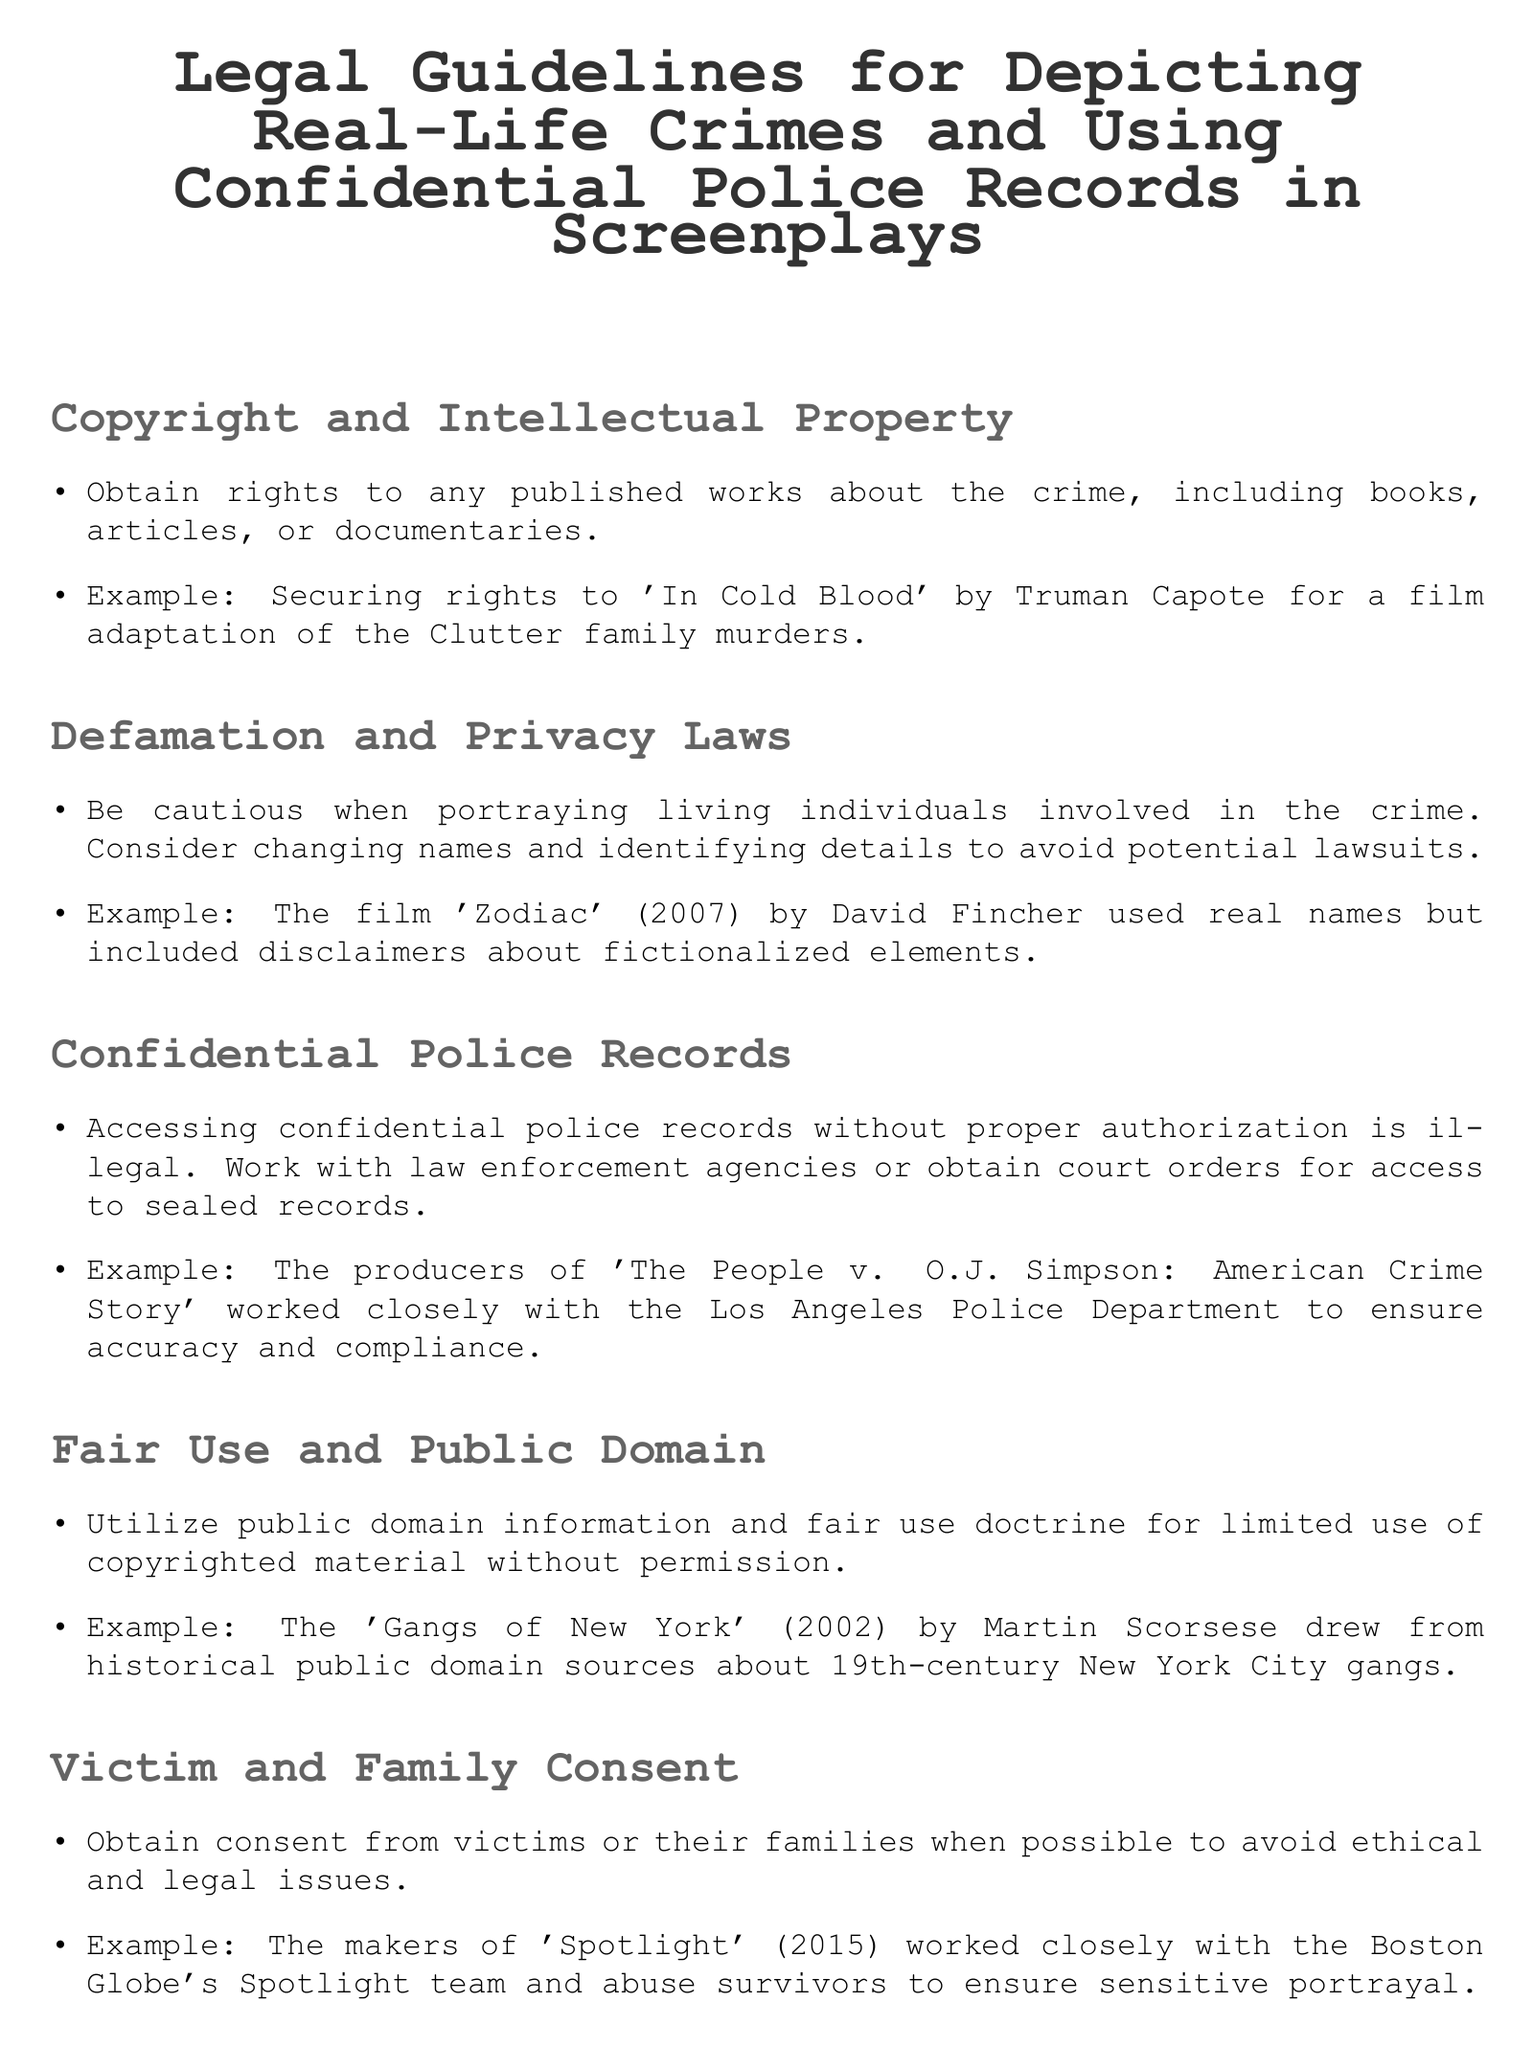What is required for using published works about a crime? The document states that rights must be obtained to use any published works about the crime.
Answer: Obtain rights What is an example of a film that changed names to avoid lawsuits? The document mentions that the film 'Zodiac' (2007) by David Fincher included disclaimers about fictionalized elements.
Answer: Zodiac What must be acquired to access confidential police records? According to the document, authorization must be obtained to access confidential police records.
Answer: Authorization Which principle allows limited use of copyrighted material without permission? The document refers to the fair use doctrine for limited use without permission.
Answer: Fair use What should filmmakers obtain from victims or their families? The document advises obtaining consent from victims or their families to avoid legal issues.
Answer: Consent What disclaimer should be included in films based on true stories? It is suggested that a disclaimer stating the film is a dramatization and events may be fictionalized should be included.
Answer: Dramatization disclaimer What film worked closely with the Boston Globe's Spotlight team? The document provides that the makers of 'Spotlight' (2015) worked closely with the Boston Globe's Spotlight team.
Answer: Spotlight What color is used for the title of the document? The document specifies that the title color is RGB (50,50,50).
Answer: RGB (50,50,50) 